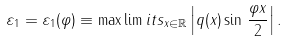Convert formula to latex. <formula><loc_0><loc_0><loc_500><loc_500>\varepsilon _ { 1 } = { \varepsilon _ { 1 } ( \varphi ) } \equiv \max \lim i t s _ { x \in { \mathbb { R } } } \left | q ( x ) \sin \, \frac { \varphi x } { 2 } \right | .</formula> 